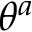<formula> <loc_0><loc_0><loc_500><loc_500>\theta ^ { a }</formula> 